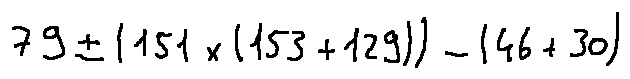<formula> <loc_0><loc_0><loc_500><loc_500>7 9 \pm ( 1 5 1 \times ( 1 5 3 + 1 2 9 ) ) - ( 4 6 + 3 0 )</formula> 